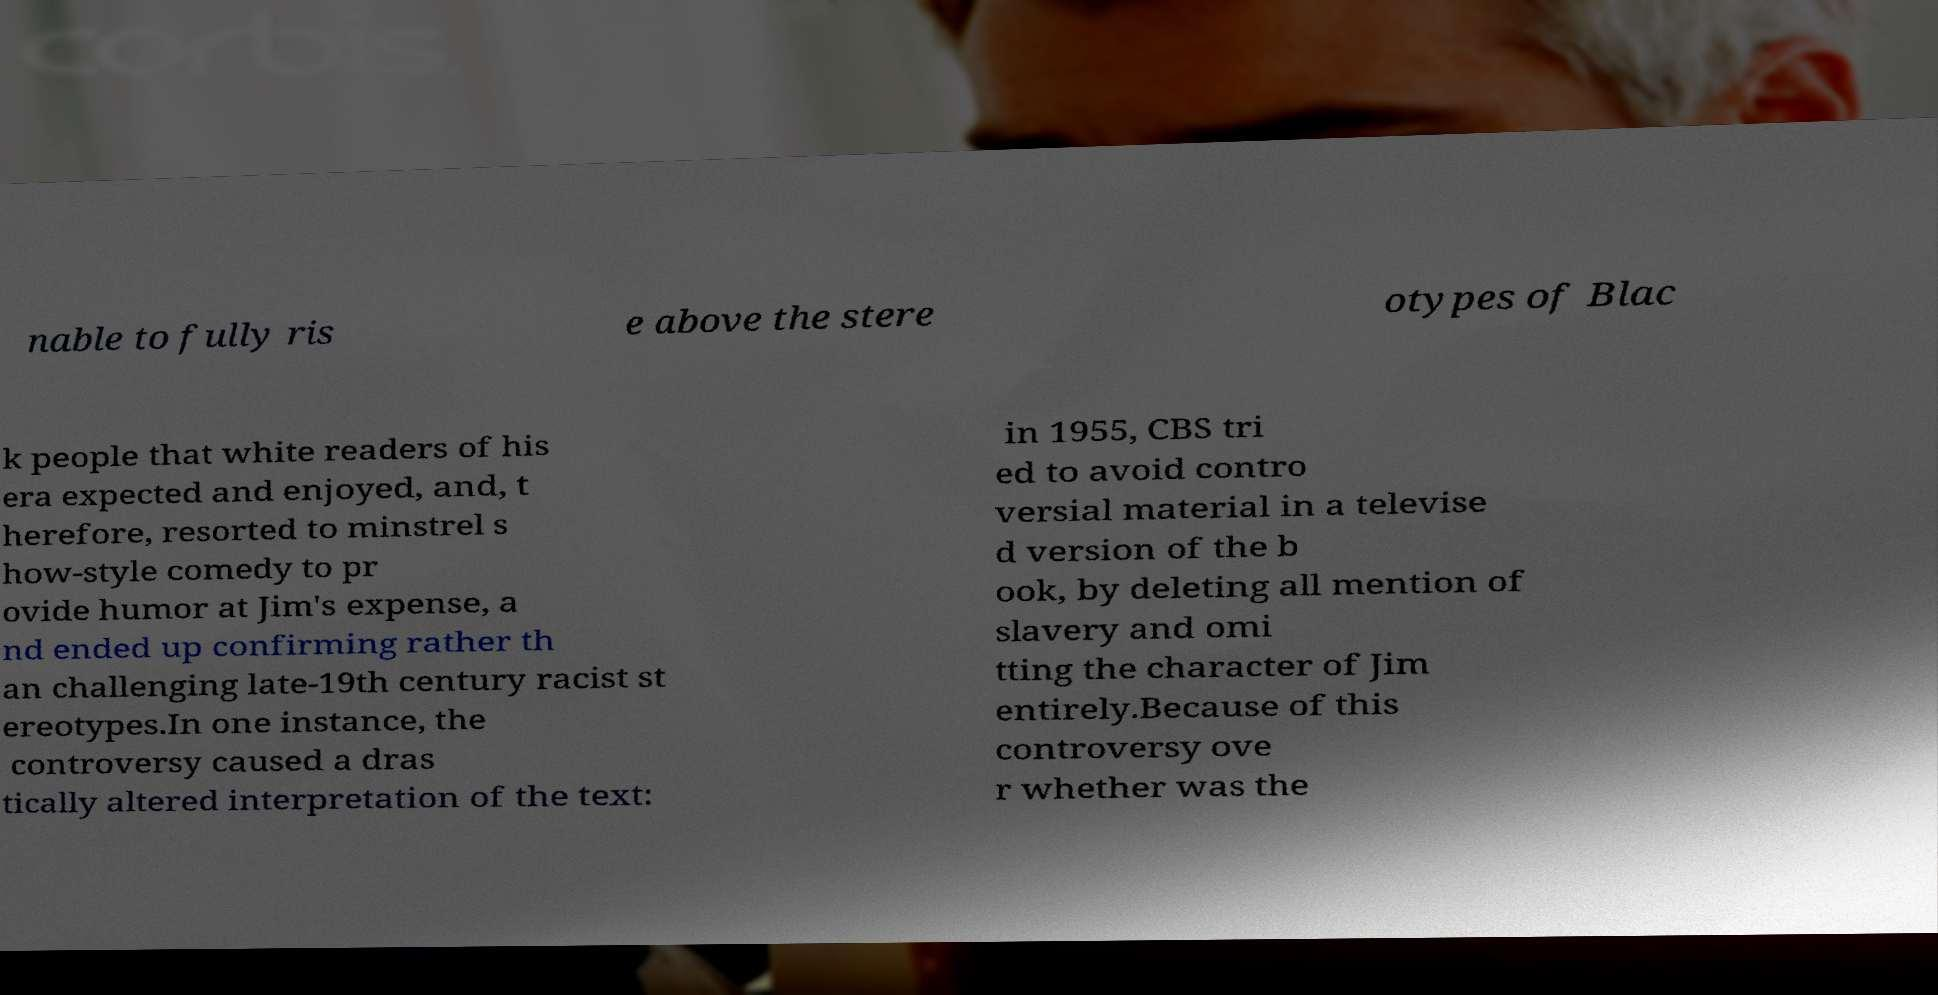Please read and relay the text visible in this image. What does it say? nable to fully ris e above the stere otypes of Blac k people that white readers of his era expected and enjoyed, and, t herefore, resorted to minstrel s how-style comedy to pr ovide humor at Jim's expense, a nd ended up confirming rather th an challenging late-19th century racist st ereotypes.In one instance, the controversy caused a dras tically altered interpretation of the text: in 1955, CBS tri ed to avoid contro versial material in a televise d version of the b ook, by deleting all mention of slavery and omi tting the character of Jim entirely.Because of this controversy ove r whether was the 